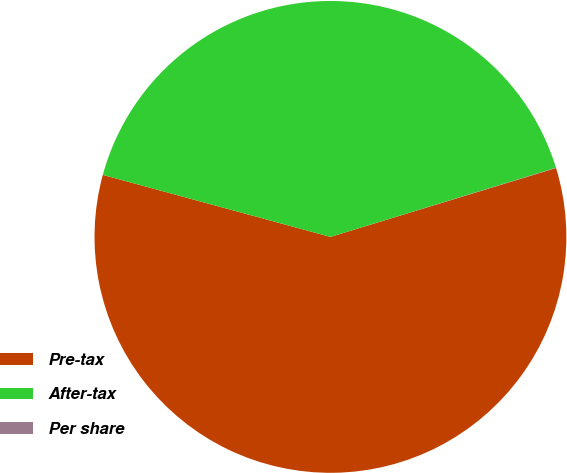Convert chart. <chart><loc_0><loc_0><loc_500><loc_500><pie_chart><fcel>Pre-tax<fcel>After-tax<fcel>Per share<nl><fcel>58.95%<fcel>41.03%<fcel>0.02%<nl></chart> 